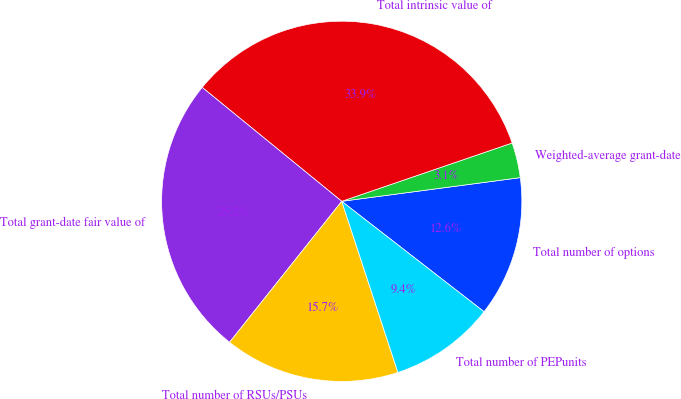Convert chart to OTSL. <chart><loc_0><loc_0><loc_500><loc_500><pie_chart><fcel>Total number of options<fcel>Weighted-average grant-date<fcel>Total intrinsic value of<fcel>Total grant-date fair value of<fcel>Total number of RSUs/PSUs<fcel>Total number of PEPunits<nl><fcel>12.6%<fcel>3.15%<fcel>33.86%<fcel>25.2%<fcel>15.75%<fcel>9.45%<nl></chart> 